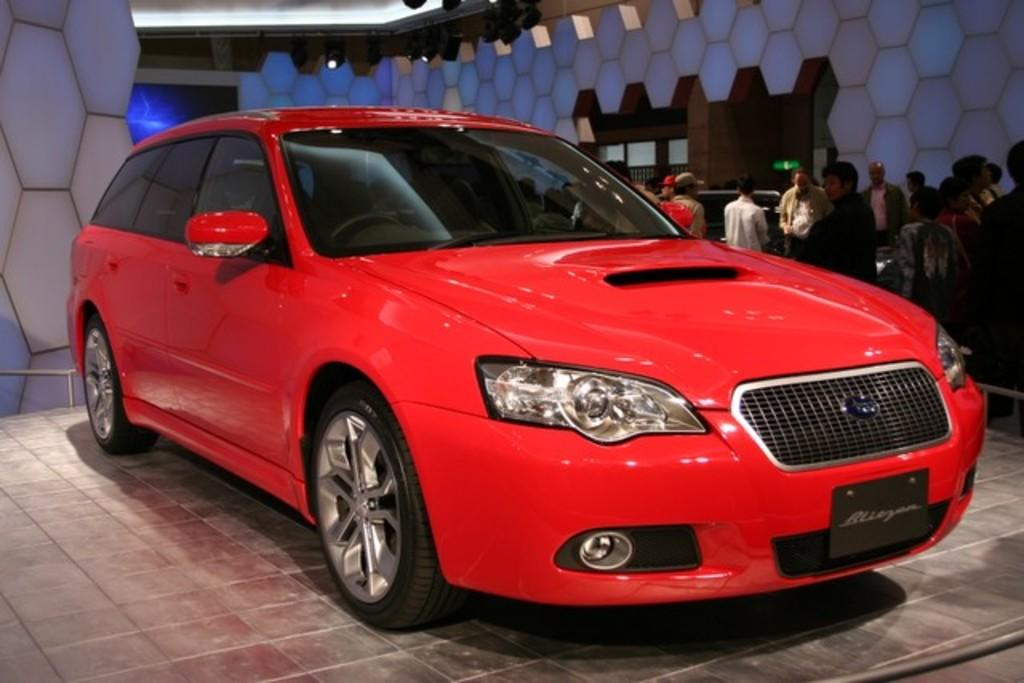What is the main subject in the center of the image? There is a car in the center of the image. Where is the car located? The car is on the floor. What can be seen in the background of the image? There are persons, a wall, and lights in the background of the image. What type of plantation can be seen in the background of the image? There is no plantation present in the image; it features a car on the floor with persons, a wall, and lights in the background. 